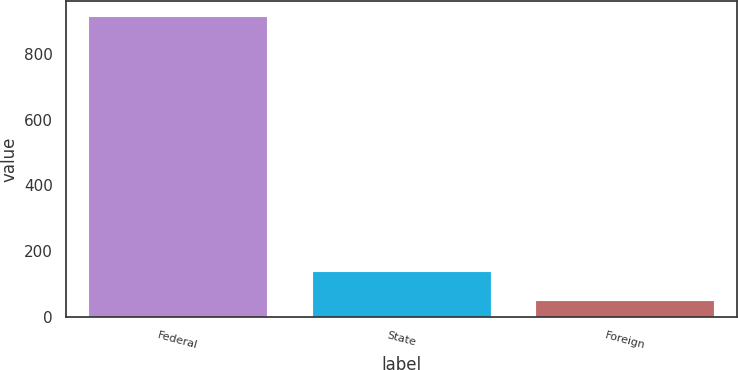Convert chart. <chart><loc_0><loc_0><loc_500><loc_500><bar_chart><fcel>Federal<fcel>State<fcel>Foreign<nl><fcel>916<fcel>138.4<fcel>52<nl></chart> 